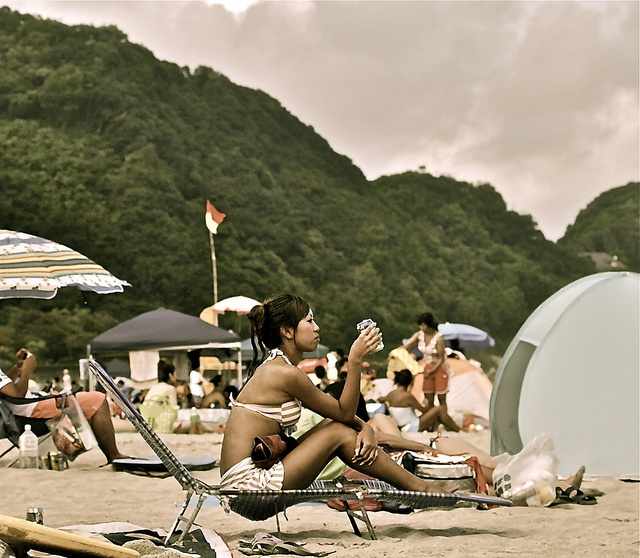Describe the objects in this image and their specific colors. I can see people in white, black, tan, maroon, and gray tones, chair in white, black, darkgreen, gray, and lightgray tones, umbrella in white, ivory, tan, darkgray, and gray tones, umbrella in white, gray, black, and darkgreen tones, and people in white, maroon, black, and gray tones in this image. 